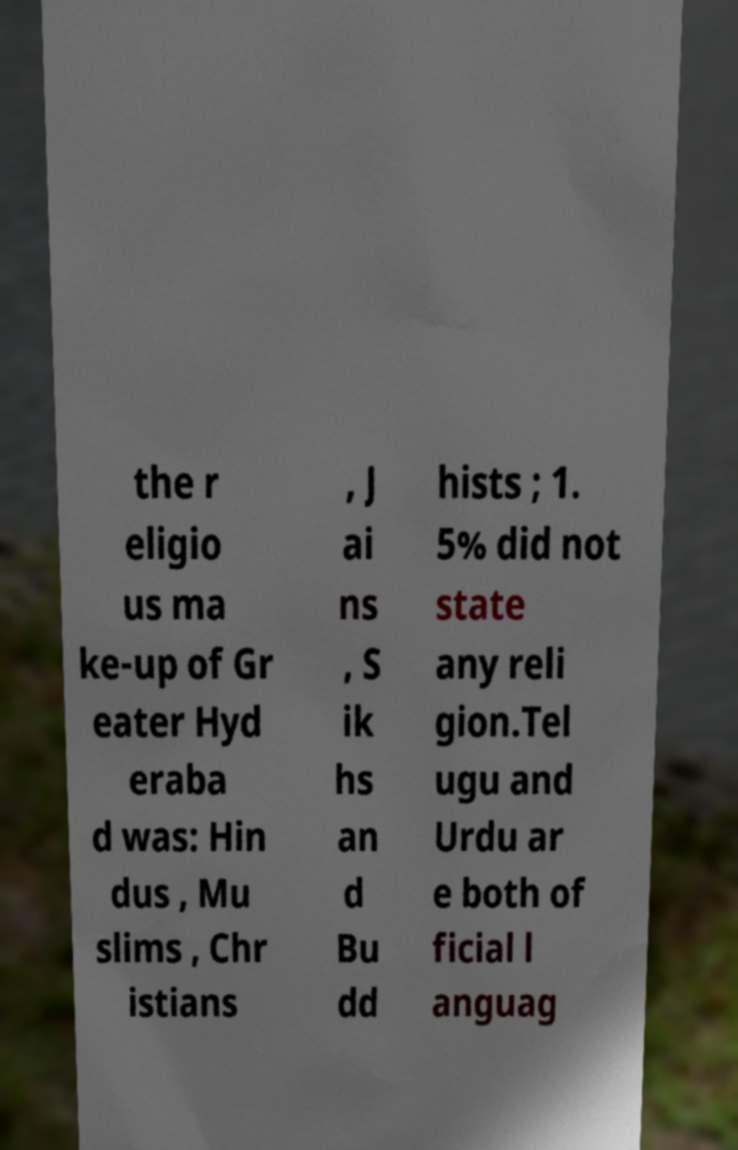For documentation purposes, I need the text within this image transcribed. Could you provide that? the r eligio us ma ke-up of Gr eater Hyd eraba d was: Hin dus , Mu slims , Chr istians , J ai ns , S ik hs an d Bu dd hists ; 1. 5% did not state any reli gion.Tel ugu and Urdu ar e both of ficial l anguag 